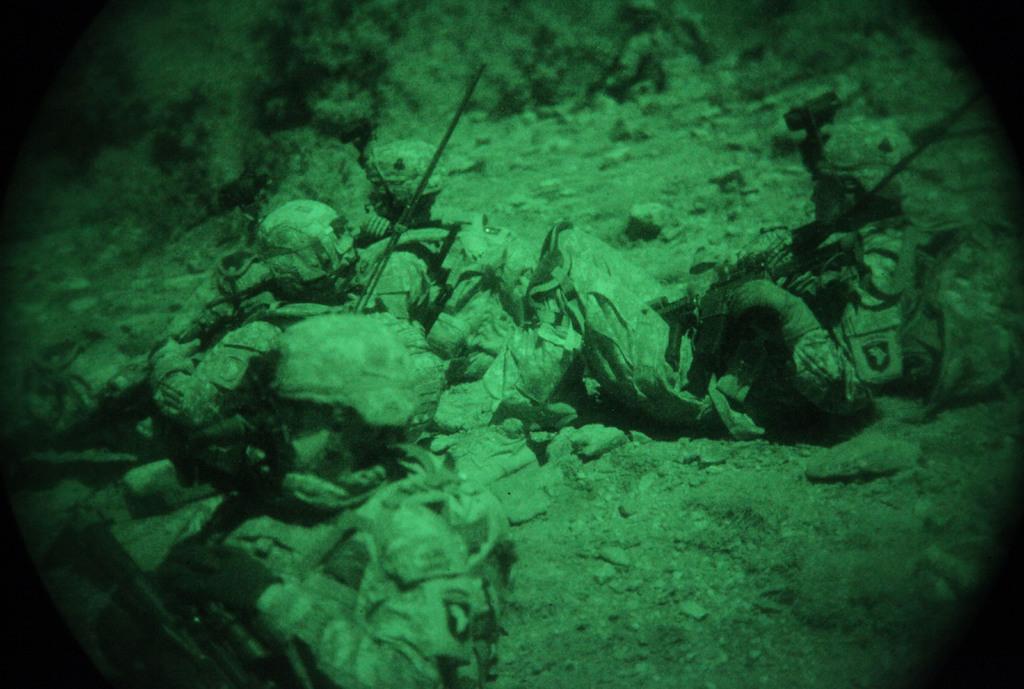How would you summarize this image in a sentence or two? In the picture there are a group of people lying on the ground. 